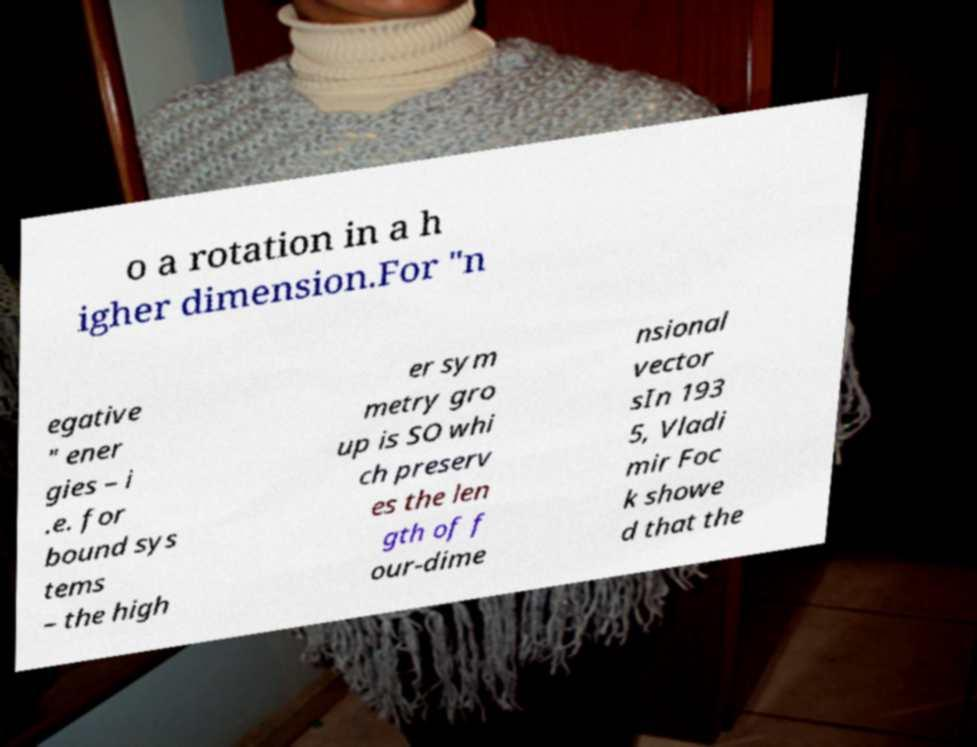Could you assist in decoding the text presented in this image and type it out clearly? o a rotation in a h igher dimension.For "n egative " ener gies – i .e. for bound sys tems – the high er sym metry gro up is SO whi ch preserv es the len gth of f our-dime nsional vector sIn 193 5, Vladi mir Foc k showe d that the 